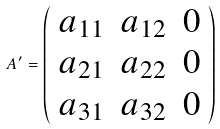Convert formula to latex. <formula><loc_0><loc_0><loc_500><loc_500>A ^ { \prime } = \left ( \begin{array} { c c c } a _ { 1 1 } & a _ { 1 2 } & 0 \\ a _ { 2 1 } & a _ { 2 2 } & 0 \\ a _ { 3 1 } & a _ { 3 2 } & 0 \end{array} \right )</formula> 